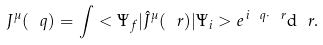Convert formula to latex. <formula><loc_0><loc_0><loc_500><loc_500>J ^ { \mu } ( \ q ) = \int < \Psi _ { f } | \hat { J } ^ { \mu } ( \ r ) | \Psi _ { i } > { e } ^ { \, { i } { \ q } \cdot { \ r } } { \mathrm d } \ r .</formula> 